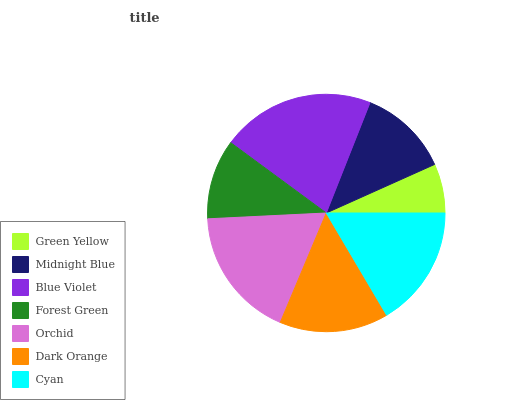Is Green Yellow the minimum?
Answer yes or no. Yes. Is Blue Violet the maximum?
Answer yes or no. Yes. Is Midnight Blue the minimum?
Answer yes or no. No. Is Midnight Blue the maximum?
Answer yes or no. No. Is Midnight Blue greater than Green Yellow?
Answer yes or no. Yes. Is Green Yellow less than Midnight Blue?
Answer yes or no. Yes. Is Green Yellow greater than Midnight Blue?
Answer yes or no. No. Is Midnight Blue less than Green Yellow?
Answer yes or no. No. Is Dark Orange the high median?
Answer yes or no. Yes. Is Dark Orange the low median?
Answer yes or no. Yes. Is Green Yellow the high median?
Answer yes or no. No. Is Cyan the low median?
Answer yes or no. No. 